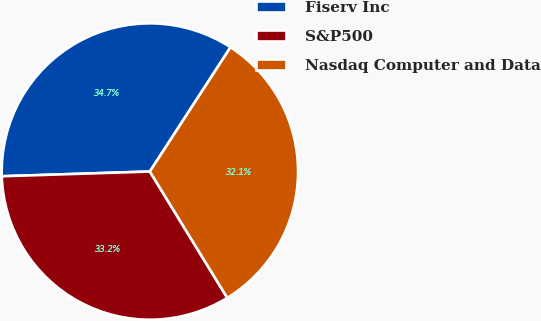<chart> <loc_0><loc_0><loc_500><loc_500><pie_chart><fcel>Fiserv Inc<fcel>S&P500<fcel>Nasdaq Computer and Data<nl><fcel>34.67%<fcel>33.24%<fcel>32.09%<nl></chart> 